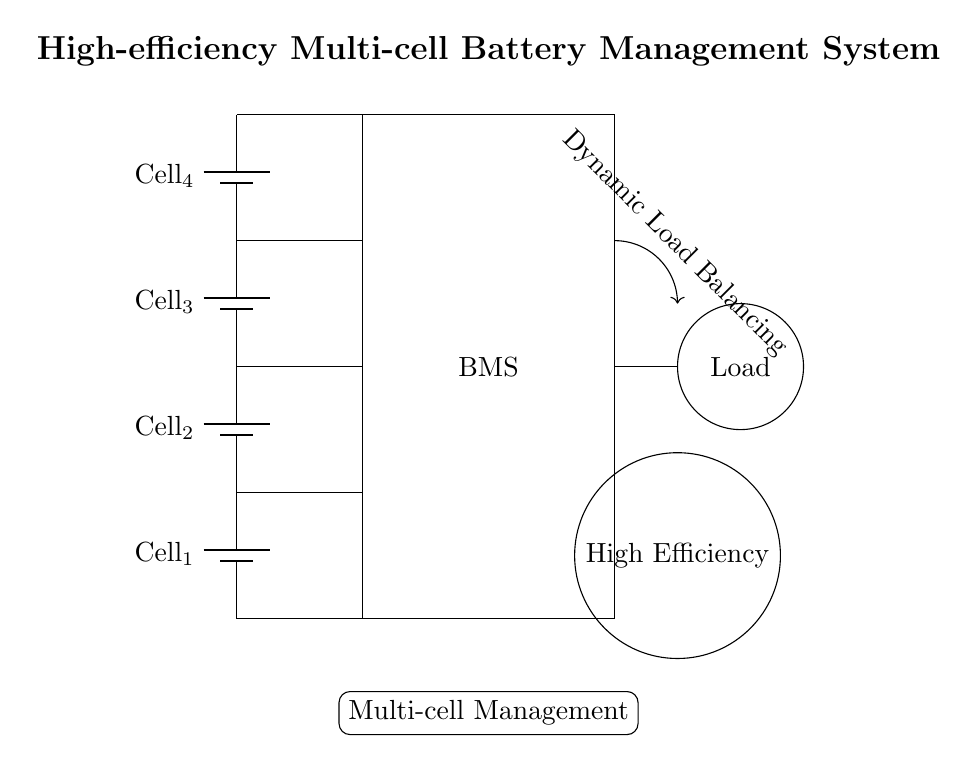What type of system is depicted in the diagram? The diagram illustrates a high-efficiency multi-cell battery management system, as indicated by the title at the top of the diagram.
Answer: high-efficiency multi-cell battery management system How many battery cells are shown in the diagram? The diagram displays four battery cells, as represented by the four battery symbols stacked vertically on the left side.
Answer: four What feature is indicated by the arrow labeled "Dynamic Load Balancing"? The arrow indicates that the circuit implements dynamic load balancing, which suggests the system is capable of redistributing the load among the cells to enhance efficiency.
Answer: Dynamic Load Balancing What does the circle with "High Efficiency" indicate? This circle is labeled "High Efficiency" indicating that the system is designed to operate with higher energy efficiency, likely through advanced management of battery cells.
Answer: High Efficiency What function does the "Multi-cell Management" label imply? The "Multi-cell Management" box indicates that this system manages multiple battery cells, coordinating their performance to optimize the overall efficiency and longevity of the battery system.
Answer: Multi-cell Management Which component is responsible for connecting to the Load? The line directly connecting to the Load comes from the BMS, indicating that the BMS is responsible for managing the connection to the load in the circuit.
Answer: BMS How is the load represented in the diagram? The load is represented as a circle with the label "Load" inside, indicating that it is the component consuming power from the battery management system.
Answer: Load 